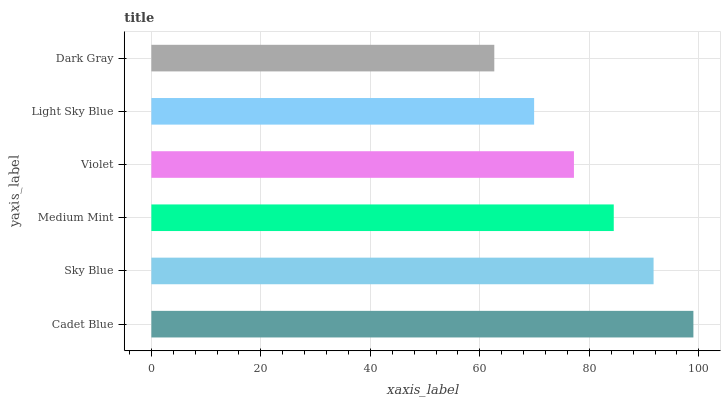Is Dark Gray the minimum?
Answer yes or no. Yes. Is Cadet Blue the maximum?
Answer yes or no. Yes. Is Sky Blue the minimum?
Answer yes or no. No. Is Sky Blue the maximum?
Answer yes or no. No. Is Cadet Blue greater than Sky Blue?
Answer yes or no. Yes. Is Sky Blue less than Cadet Blue?
Answer yes or no. Yes. Is Sky Blue greater than Cadet Blue?
Answer yes or no. No. Is Cadet Blue less than Sky Blue?
Answer yes or no. No. Is Medium Mint the high median?
Answer yes or no. Yes. Is Violet the low median?
Answer yes or no. Yes. Is Dark Gray the high median?
Answer yes or no. No. Is Light Sky Blue the low median?
Answer yes or no. No. 